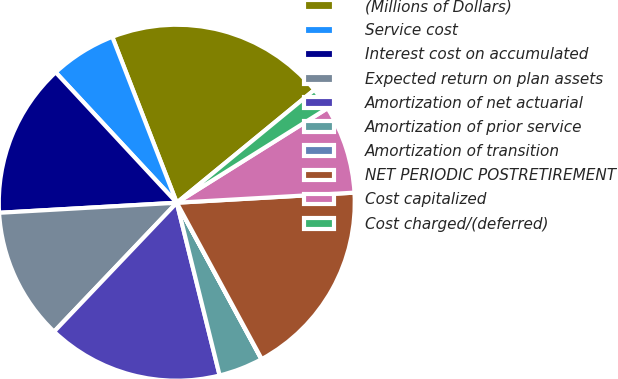<chart> <loc_0><loc_0><loc_500><loc_500><pie_chart><fcel>(Millions of Dollars)<fcel>Service cost<fcel>Interest cost on accumulated<fcel>Expected return on plan assets<fcel>Amortization of net actuarial<fcel>Amortization of prior service<fcel>Amortization of transition<fcel>NET PERIODIC POSTRETIREMENT<fcel>Cost capitalized<fcel>Cost charged/(deferred)<nl><fcel>19.97%<fcel>6.01%<fcel>13.99%<fcel>11.99%<fcel>15.98%<fcel>4.02%<fcel>0.03%<fcel>17.98%<fcel>8.01%<fcel>2.02%<nl></chart> 